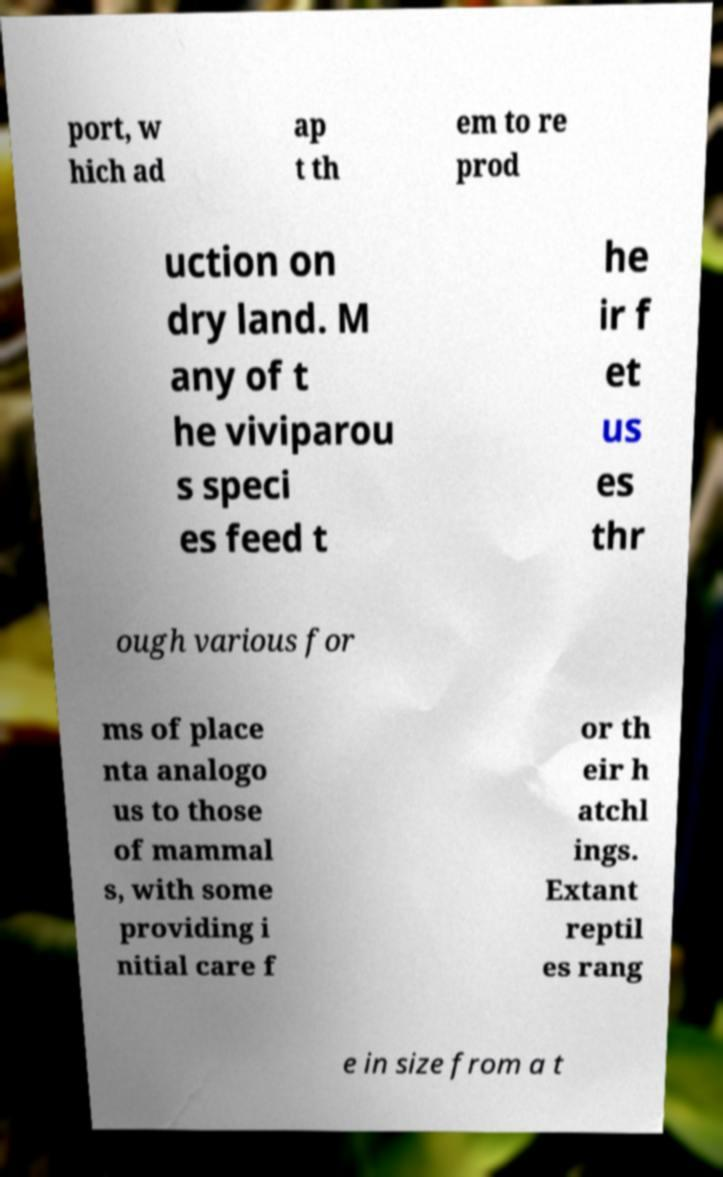Could you extract and type out the text from this image? port, w hich ad ap t th em to re prod uction on dry land. M any of t he viviparou s speci es feed t he ir f et us es thr ough various for ms of place nta analogo us to those of mammal s, with some providing i nitial care f or th eir h atchl ings. Extant reptil es rang e in size from a t 